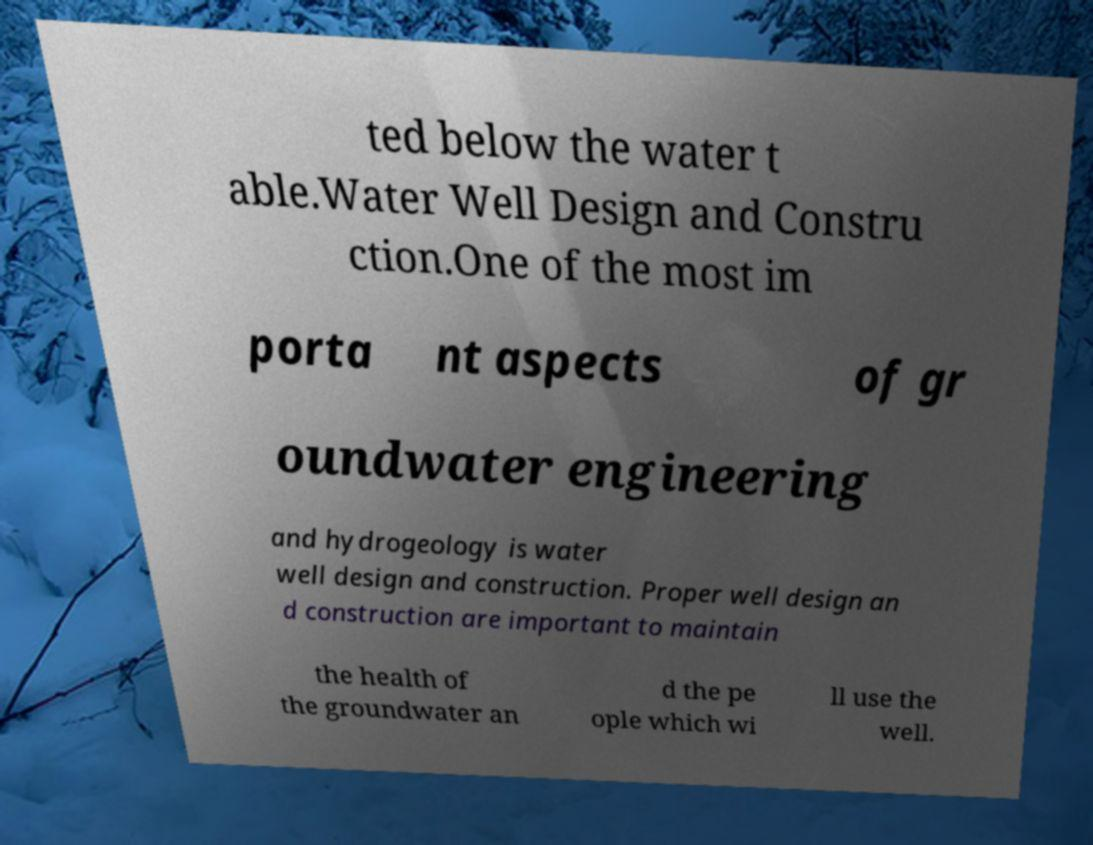What messages or text are displayed in this image? I need them in a readable, typed format. ted below the water t able.Water Well Design and Constru ction.One of the most im porta nt aspects of gr oundwater engineering and hydrogeology is water well design and construction. Proper well design an d construction are important to maintain the health of the groundwater an d the pe ople which wi ll use the well. 